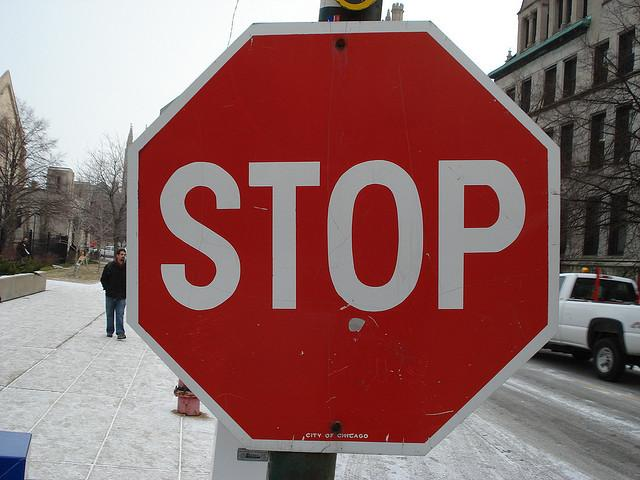This city's name comes from a Native American word for what? Please explain your reasoning. onion. Chicago's name meaning in the algonquin language. 